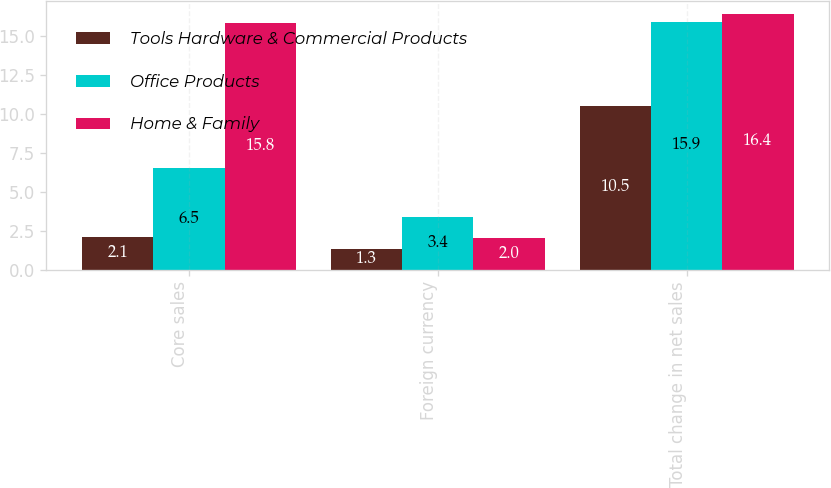<chart> <loc_0><loc_0><loc_500><loc_500><stacked_bar_chart><ecel><fcel>Core sales<fcel>Foreign currency<fcel>Total change in net sales<nl><fcel>Tools Hardware & Commercial Products<fcel>2.1<fcel>1.3<fcel>10.5<nl><fcel>Office Products<fcel>6.5<fcel>3.4<fcel>15.9<nl><fcel>Home & Family<fcel>15.8<fcel>2<fcel>16.4<nl></chart> 